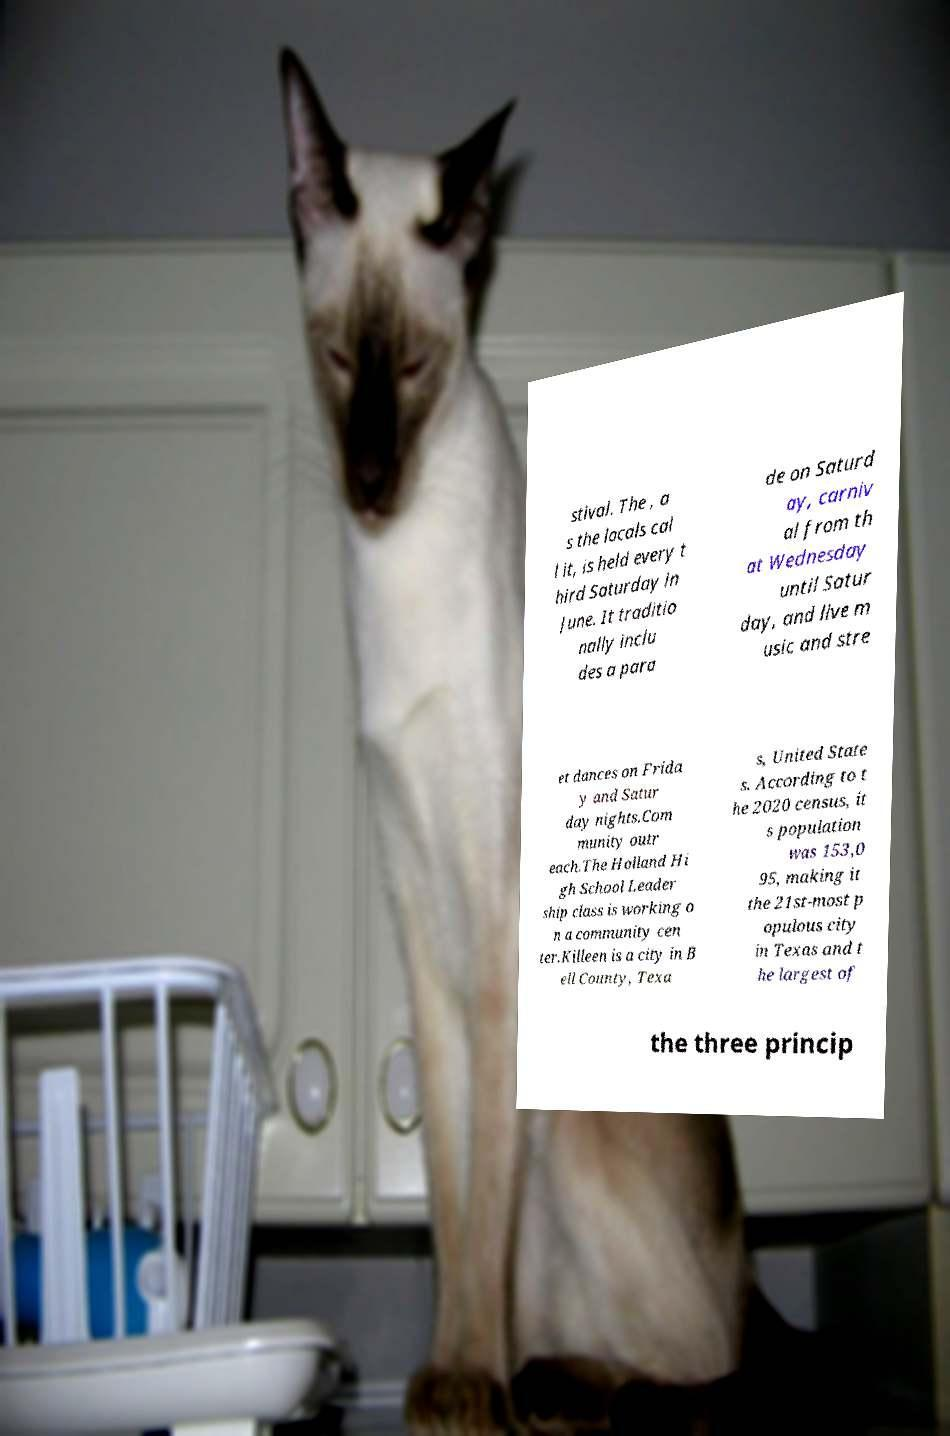Could you assist in decoding the text presented in this image and type it out clearly? stival. The , a s the locals cal l it, is held every t hird Saturday in June. It traditio nally inclu des a para de on Saturd ay, carniv al from th at Wednesday until Satur day, and live m usic and stre et dances on Frida y and Satur day nights.Com munity outr each.The Holland Hi gh School Leader ship class is working o n a community cen ter.Killeen is a city in B ell County, Texa s, United State s. According to t he 2020 census, it s population was 153,0 95, making it the 21st-most p opulous city in Texas and t he largest of the three princip 